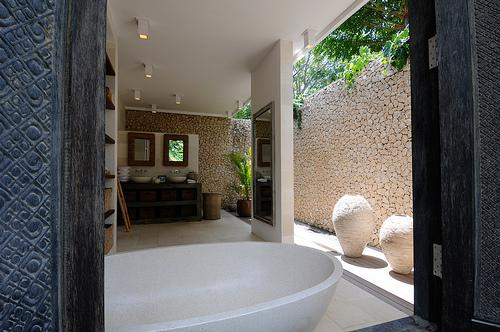Question: how many light fixtures on the ceiling?
Choices:
A. 8.
B. 6.
C. 7.
D. 3.
Answer with the letter. Answer: A Question: where are the sinks?
Choices:
A. In the kitchen.
B. In the bathroom.
C. On the far wall.
D. In the garage.
Answer with the letter. Answer: C Question: when was the photo taken?
Choices:
A. Morning.
B. Afternoon.
C. Evening.
D. During the day.
Answer with the letter. Answer: D Question: how many people are in the picture?
Choices:
A. Zero.
B. One.
C. Two.
D. Three.
Answer with the letter. Answer: A Question: what material is the wall made of?
Choices:
A. Brick.
B. Concrete.
C. Stucco.
D. Stone.
Answer with the letter. Answer: D 